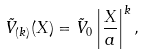Convert formula to latex. <formula><loc_0><loc_0><loc_500><loc_500>\tilde { V } _ { ( k ) } ( X ) = \tilde { V } _ { 0 } \left | \frac { X } { a } \right | ^ { k } ,</formula> 